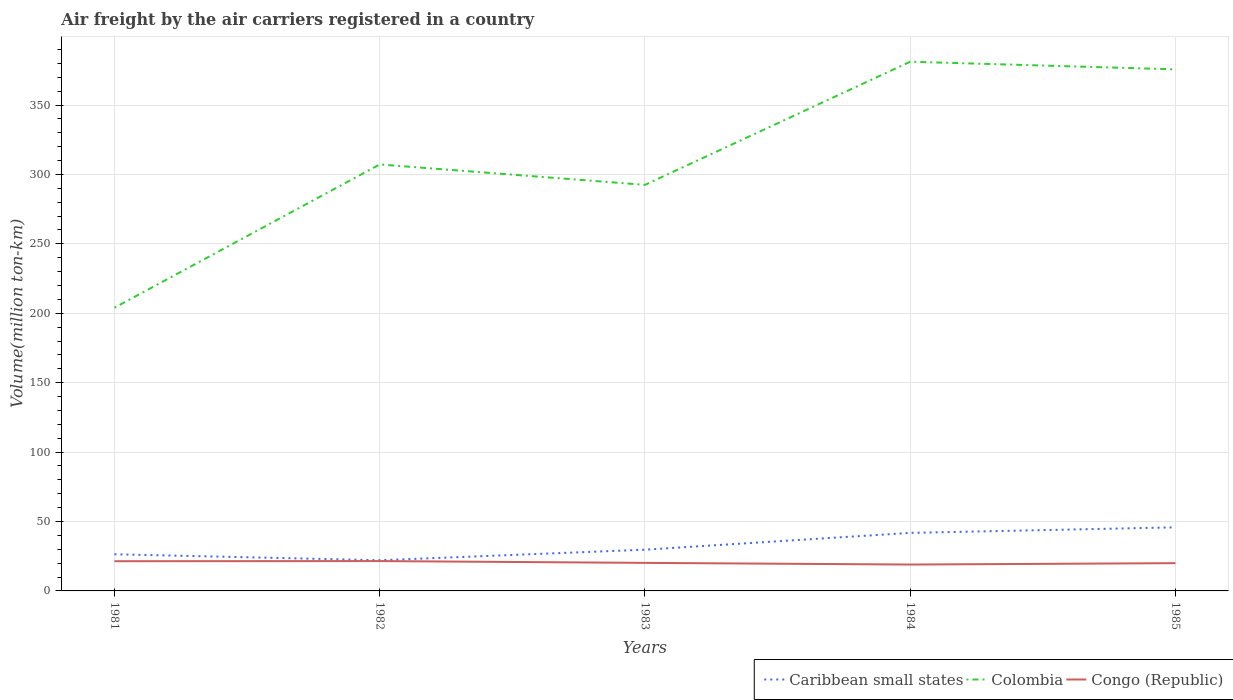How many different coloured lines are there?
Provide a succinct answer. 3. Does the line corresponding to Colombia intersect with the line corresponding to Congo (Republic)?
Provide a succinct answer. No. Across all years, what is the maximum volume of the air carriers in Congo (Republic)?
Ensure brevity in your answer.  19. What is the difference between the highest and the second highest volume of the air carriers in Colombia?
Provide a short and direct response. 177.2. Is the volume of the air carriers in Colombia strictly greater than the volume of the air carriers in Caribbean small states over the years?
Give a very brief answer. No. How many lines are there?
Give a very brief answer. 3. How many years are there in the graph?
Keep it short and to the point. 5. Are the values on the major ticks of Y-axis written in scientific E-notation?
Offer a very short reply. No. Does the graph contain any zero values?
Offer a very short reply. No. Does the graph contain grids?
Your response must be concise. Yes. How are the legend labels stacked?
Provide a short and direct response. Horizontal. What is the title of the graph?
Keep it short and to the point. Air freight by the air carriers registered in a country. Does "Malawi" appear as one of the legend labels in the graph?
Provide a succinct answer. No. What is the label or title of the Y-axis?
Your answer should be very brief. Volume(million ton-km). What is the Volume(million ton-km) of Caribbean small states in 1981?
Your answer should be very brief. 26.4. What is the Volume(million ton-km) of Colombia in 1981?
Your response must be concise. 204. What is the Volume(million ton-km) of Congo (Republic) in 1981?
Make the answer very short. 21.4. What is the Volume(million ton-km) in Caribbean small states in 1982?
Provide a short and direct response. 22.1. What is the Volume(million ton-km) of Colombia in 1982?
Give a very brief answer. 307.2. What is the Volume(million ton-km) in Caribbean small states in 1983?
Keep it short and to the point. 29.7. What is the Volume(million ton-km) of Colombia in 1983?
Make the answer very short. 292.5. What is the Volume(million ton-km) in Congo (Republic) in 1983?
Your answer should be compact. 20.2. What is the Volume(million ton-km) in Caribbean small states in 1984?
Ensure brevity in your answer.  41.8. What is the Volume(million ton-km) of Colombia in 1984?
Give a very brief answer. 381.2. What is the Volume(million ton-km) in Caribbean small states in 1985?
Give a very brief answer. 45.8. What is the Volume(million ton-km) of Colombia in 1985?
Ensure brevity in your answer.  375.7. What is the Volume(million ton-km) in Congo (Republic) in 1985?
Your answer should be very brief. 20. Across all years, what is the maximum Volume(million ton-km) of Caribbean small states?
Provide a short and direct response. 45.8. Across all years, what is the maximum Volume(million ton-km) in Colombia?
Keep it short and to the point. 381.2. Across all years, what is the minimum Volume(million ton-km) of Caribbean small states?
Provide a short and direct response. 22.1. Across all years, what is the minimum Volume(million ton-km) in Colombia?
Your answer should be very brief. 204. Across all years, what is the minimum Volume(million ton-km) in Congo (Republic)?
Your response must be concise. 19. What is the total Volume(million ton-km) of Caribbean small states in the graph?
Your answer should be very brief. 165.8. What is the total Volume(million ton-km) of Colombia in the graph?
Your response must be concise. 1560.6. What is the total Volume(million ton-km) in Congo (Republic) in the graph?
Provide a succinct answer. 102.1. What is the difference between the Volume(million ton-km) of Colombia in 1981 and that in 1982?
Offer a very short reply. -103.2. What is the difference between the Volume(million ton-km) in Caribbean small states in 1981 and that in 1983?
Offer a terse response. -3.3. What is the difference between the Volume(million ton-km) in Colombia in 1981 and that in 1983?
Offer a terse response. -88.5. What is the difference between the Volume(million ton-km) in Congo (Republic) in 1981 and that in 1983?
Offer a very short reply. 1.2. What is the difference between the Volume(million ton-km) of Caribbean small states in 1981 and that in 1984?
Give a very brief answer. -15.4. What is the difference between the Volume(million ton-km) of Colombia in 1981 and that in 1984?
Offer a terse response. -177.2. What is the difference between the Volume(million ton-km) in Congo (Republic) in 1981 and that in 1984?
Your response must be concise. 2.4. What is the difference between the Volume(million ton-km) in Caribbean small states in 1981 and that in 1985?
Offer a very short reply. -19.4. What is the difference between the Volume(million ton-km) in Colombia in 1981 and that in 1985?
Ensure brevity in your answer.  -171.7. What is the difference between the Volume(million ton-km) in Caribbean small states in 1982 and that in 1984?
Keep it short and to the point. -19.7. What is the difference between the Volume(million ton-km) in Colombia in 1982 and that in 1984?
Offer a terse response. -74. What is the difference between the Volume(million ton-km) of Caribbean small states in 1982 and that in 1985?
Offer a very short reply. -23.7. What is the difference between the Volume(million ton-km) of Colombia in 1982 and that in 1985?
Keep it short and to the point. -68.5. What is the difference between the Volume(million ton-km) in Colombia in 1983 and that in 1984?
Your response must be concise. -88.7. What is the difference between the Volume(million ton-km) of Congo (Republic) in 1983 and that in 1984?
Provide a short and direct response. 1.2. What is the difference between the Volume(million ton-km) in Caribbean small states in 1983 and that in 1985?
Make the answer very short. -16.1. What is the difference between the Volume(million ton-km) in Colombia in 1983 and that in 1985?
Make the answer very short. -83.2. What is the difference between the Volume(million ton-km) in Congo (Republic) in 1983 and that in 1985?
Give a very brief answer. 0.2. What is the difference between the Volume(million ton-km) of Congo (Republic) in 1984 and that in 1985?
Your answer should be very brief. -1. What is the difference between the Volume(million ton-km) of Caribbean small states in 1981 and the Volume(million ton-km) of Colombia in 1982?
Offer a very short reply. -280.8. What is the difference between the Volume(million ton-km) in Colombia in 1981 and the Volume(million ton-km) in Congo (Republic) in 1982?
Offer a terse response. 182.5. What is the difference between the Volume(million ton-km) of Caribbean small states in 1981 and the Volume(million ton-km) of Colombia in 1983?
Your answer should be compact. -266.1. What is the difference between the Volume(million ton-km) of Colombia in 1981 and the Volume(million ton-km) of Congo (Republic) in 1983?
Your response must be concise. 183.8. What is the difference between the Volume(million ton-km) of Caribbean small states in 1981 and the Volume(million ton-km) of Colombia in 1984?
Your response must be concise. -354.8. What is the difference between the Volume(million ton-km) in Colombia in 1981 and the Volume(million ton-km) in Congo (Republic) in 1984?
Your answer should be very brief. 185. What is the difference between the Volume(million ton-km) in Caribbean small states in 1981 and the Volume(million ton-km) in Colombia in 1985?
Offer a very short reply. -349.3. What is the difference between the Volume(million ton-km) of Colombia in 1981 and the Volume(million ton-km) of Congo (Republic) in 1985?
Provide a succinct answer. 184. What is the difference between the Volume(million ton-km) in Caribbean small states in 1982 and the Volume(million ton-km) in Colombia in 1983?
Provide a short and direct response. -270.4. What is the difference between the Volume(million ton-km) of Colombia in 1982 and the Volume(million ton-km) of Congo (Republic) in 1983?
Provide a succinct answer. 287. What is the difference between the Volume(million ton-km) of Caribbean small states in 1982 and the Volume(million ton-km) of Colombia in 1984?
Your response must be concise. -359.1. What is the difference between the Volume(million ton-km) in Colombia in 1982 and the Volume(million ton-km) in Congo (Republic) in 1984?
Give a very brief answer. 288.2. What is the difference between the Volume(million ton-km) in Caribbean small states in 1982 and the Volume(million ton-km) in Colombia in 1985?
Your answer should be compact. -353.6. What is the difference between the Volume(million ton-km) in Colombia in 1982 and the Volume(million ton-km) in Congo (Republic) in 1985?
Your answer should be compact. 287.2. What is the difference between the Volume(million ton-km) of Caribbean small states in 1983 and the Volume(million ton-km) of Colombia in 1984?
Give a very brief answer. -351.5. What is the difference between the Volume(million ton-km) of Caribbean small states in 1983 and the Volume(million ton-km) of Congo (Republic) in 1984?
Your answer should be very brief. 10.7. What is the difference between the Volume(million ton-km) in Colombia in 1983 and the Volume(million ton-km) in Congo (Republic) in 1984?
Ensure brevity in your answer.  273.5. What is the difference between the Volume(million ton-km) in Caribbean small states in 1983 and the Volume(million ton-km) in Colombia in 1985?
Your answer should be very brief. -346. What is the difference between the Volume(million ton-km) of Caribbean small states in 1983 and the Volume(million ton-km) of Congo (Republic) in 1985?
Offer a very short reply. 9.7. What is the difference between the Volume(million ton-km) in Colombia in 1983 and the Volume(million ton-km) in Congo (Republic) in 1985?
Offer a very short reply. 272.5. What is the difference between the Volume(million ton-km) in Caribbean small states in 1984 and the Volume(million ton-km) in Colombia in 1985?
Keep it short and to the point. -333.9. What is the difference between the Volume(million ton-km) in Caribbean small states in 1984 and the Volume(million ton-km) in Congo (Republic) in 1985?
Provide a short and direct response. 21.8. What is the difference between the Volume(million ton-km) in Colombia in 1984 and the Volume(million ton-km) in Congo (Republic) in 1985?
Offer a terse response. 361.2. What is the average Volume(million ton-km) in Caribbean small states per year?
Your answer should be compact. 33.16. What is the average Volume(million ton-km) in Colombia per year?
Ensure brevity in your answer.  312.12. What is the average Volume(million ton-km) in Congo (Republic) per year?
Keep it short and to the point. 20.42. In the year 1981, what is the difference between the Volume(million ton-km) in Caribbean small states and Volume(million ton-km) in Colombia?
Ensure brevity in your answer.  -177.6. In the year 1981, what is the difference between the Volume(million ton-km) of Caribbean small states and Volume(million ton-km) of Congo (Republic)?
Provide a short and direct response. 5. In the year 1981, what is the difference between the Volume(million ton-km) in Colombia and Volume(million ton-km) in Congo (Republic)?
Provide a short and direct response. 182.6. In the year 1982, what is the difference between the Volume(million ton-km) in Caribbean small states and Volume(million ton-km) in Colombia?
Offer a very short reply. -285.1. In the year 1982, what is the difference between the Volume(million ton-km) in Caribbean small states and Volume(million ton-km) in Congo (Republic)?
Offer a terse response. 0.6. In the year 1982, what is the difference between the Volume(million ton-km) of Colombia and Volume(million ton-km) of Congo (Republic)?
Offer a terse response. 285.7. In the year 1983, what is the difference between the Volume(million ton-km) of Caribbean small states and Volume(million ton-km) of Colombia?
Keep it short and to the point. -262.8. In the year 1983, what is the difference between the Volume(million ton-km) of Caribbean small states and Volume(million ton-km) of Congo (Republic)?
Keep it short and to the point. 9.5. In the year 1983, what is the difference between the Volume(million ton-km) in Colombia and Volume(million ton-km) in Congo (Republic)?
Your answer should be very brief. 272.3. In the year 1984, what is the difference between the Volume(million ton-km) in Caribbean small states and Volume(million ton-km) in Colombia?
Keep it short and to the point. -339.4. In the year 1984, what is the difference between the Volume(million ton-km) in Caribbean small states and Volume(million ton-km) in Congo (Republic)?
Make the answer very short. 22.8. In the year 1984, what is the difference between the Volume(million ton-km) of Colombia and Volume(million ton-km) of Congo (Republic)?
Your answer should be very brief. 362.2. In the year 1985, what is the difference between the Volume(million ton-km) in Caribbean small states and Volume(million ton-km) in Colombia?
Your response must be concise. -329.9. In the year 1985, what is the difference between the Volume(million ton-km) of Caribbean small states and Volume(million ton-km) of Congo (Republic)?
Keep it short and to the point. 25.8. In the year 1985, what is the difference between the Volume(million ton-km) in Colombia and Volume(million ton-km) in Congo (Republic)?
Make the answer very short. 355.7. What is the ratio of the Volume(million ton-km) of Caribbean small states in 1981 to that in 1982?
Your response must be concise. 1.19. What is the ratio of the Volume(million ton-km) in Colombia in 1981 to that in 1982?
Your answer should be compact. 0.66. What is the ratio of the Volume(million ton-km) in Congo (Republic) in 1981 to that in 1982?
Provide a short and direct response. 1. What is the ratio of the Volume(million ton-km) in Caribbean small states in 1981 to that in 1983?
Give a very brief answer. 0.89. What is the ratio of the Volume(million ton-km) of Colombia in 1981 to that in 1983?
Your answer should be very brief. 0.7. What is the ratio of the Volume(million ton-km) of Congo (Republic) in 1981 to that in 1983?
Make the answer very short. 1.06. What is the ratio of the Volume(million ton-km) of Caribbean small states in 1981 to that in 1984?
Make the answer very short. 0.63. What is the ratio of the Volume(million ton-km) of Colombia in 1981 to that in 1984?
Provide a short and direct response. 0.54. What is the ratio of the Volume(million ton-km) in Congo (Republic) in 1981 to that in 1984?
Your answer should be compact. 1.13. What is the ratio of the Volume(million ton-km) in Caribbean small states in 1981 to that in 1985?
Your response must be concise. 0.58. What is the ratio of the Volume(million ton-km) in Colombia in 1981 to that in 1985?
Give a very brief answer. 0.54. What is the ratio of the Volume(million ton-km) in Congo (Republic) in 1981 to that in 1985?
Offer a very short reply. 1.07. What is the ratio of the Volume(million ton-km) of Caribbean small states in 1982 to that in 1983?
Make the answer very short. 0.74. What is the ratio of the Volume(million ton-km) of Colombia in 1982 to that in 1983?
Offer a terse response. 1.05. What is the ratio of the Volume(million ton-km) of Congo (Republic) in 1982 to that in 1983?
Your answer should be very brief. 1.06. What is the ratio of the Volume(million ton-km) of Caribbean small states in 1982 to that in 1984?
Your response must be concise. 0.53. What is the ratio of the Volume(million ton-km) of Colombia in 1982 to that in 1984?
Offer a very short reply. 0.81. What is the ratio of the Volume(million ton-km) in Congo (Republic) in 1982 to that in 1984?
Give a very brief answer. 1.13. What is the ratio of the Volume(million ton-km) of Caribbean small states in 1982 to that in 1985?
Your response must be concise. 0.48. What is the ratio of the Volume(million ton-km) in Colombia in 1982 to that in 1985?
Your response must be concise. 0.82. What is the ratio of the Volume(million ton-km) of Congo (Republic) in 1982 to that in 1985?
Offer a very short reply. 1.07. What is the ratio of the Volume(million ton-km) in Caribbean small states in 1983 to that in 1984?
Provide a succinct answer. 0.71. What is the ratio of the Volume(million ton-km) of Colombia in 1983 to that in 1984?
Your response must be concise. 0.77. What is the ratio of the Volume(million ton-km) in Congo (Republic) in 1983 to that in 1984?
Keep it short and to the point. 1.06. What is the ratio of the Volume(million ton-km) in Caribbean small states in 1983 to that in 1985?
Keep it short and to the point. 0.65. What is the ratio of the Volume(million ton-km) in Colombia in 1983 to that in 1985?
Make the answer very short. 0.78. What is the ratio of the Volume(million ton-km) in Congo (Republic) in 1983 to that in 1985?
Give a very brief answer. 1.01. What is the ratio of the Volume(million ton-km) of Caribbean small states in 1984 to that in 1985?
Provide a short and direct response. 0.91. What is the ratio of the Volume(million ton-km) in Colombia in 1984 to that in 1985?
Your response must be concise. 1.01. What is the difference between the highest and the second highest Volume(million ton-km) of Caribbean small states?
Ensure brevity in your answer.  4. What is the difference between the highest and the second highest Volume(million ton-km) in Colombia?
Make the answer very short. 5.5. What is the difference between the highest and the lowest Volume(million ton-km) in Caribbean small states?
Offer a terse response. 23.7. What is the difference between the highest and the lowest Volume(million ton-km) in Colombia?
Give a very brief answer. 177.2. 